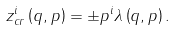<formula> <loc_0><loc_0><loc_500><loc_500>z _ { c r } ^ { i } \left ( q , p \right ) = \pm p ^ { i } \lambda \left ( q , p \right ) .</formula> 